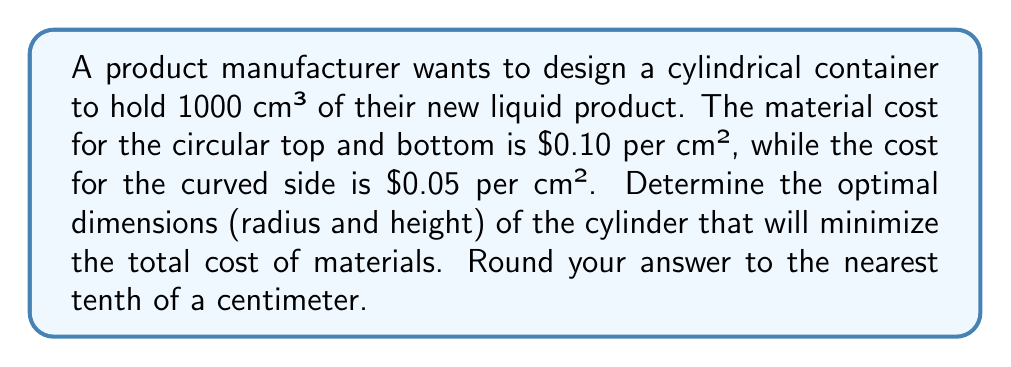Can you answer this question? Let's approach this step-by-step using optimization techniques:

1) Let $r$ be the radius and $h$ be the height of the cylinder.

2) The volume of a cylinder is given by $V = \pi r^2 h$. We know $V = 1000$ cm³, so:

   $$1000 = \pi r^2 h$$

3) Solve for $h$:

   $$h = \frac{1000}{\pi r^2}$$

4) The surface area of a cylinder consists of two circular ends and the curved side:
   
   Area of ends: $2\pi r^2$
   Area of side: $2\pi rh$

5) The cost function $C$ is:

   $$C = 0.10(2\pi r^2) + 0.05(2\pi rh)$$

6) Substitute $h$ from step 3:

   $$C = 0.20\pi r^2 + 0.10\pi r(\frac{1000}{\pi r^2})$$
   $$C = 0.20\pi r^2 + \frac{100}{r}$$

7) To find the minimum cost, differentiate $C$ with respect to $r$ and set it to zero:

   $$\frac{dC}{dr} = 0.40\pi r - \frac{100}{r^2} = 0$$

8) Solve this equation:

   $$0.40\pi r^3 = 100$$
   $$r^3 = \frac{100}{0.40\pi} = \frac{250}{\pi}$$
   $$r = \sqrt[3]{\frac{250}{\pi}} \approx 5.4$ cm$$

9) Calculate $h$ using the equation from step 3:

   $$h = \frac{1000}{\pi (5.4)^2} \approx 10.9$ cm$$

Therefore, the optimal dimensions are approximately $r = 5.4$ cm and $h = 10.9$ cm.
Answer: $r \approx 5.4$ cm, $h \approx 10.9$ cm 